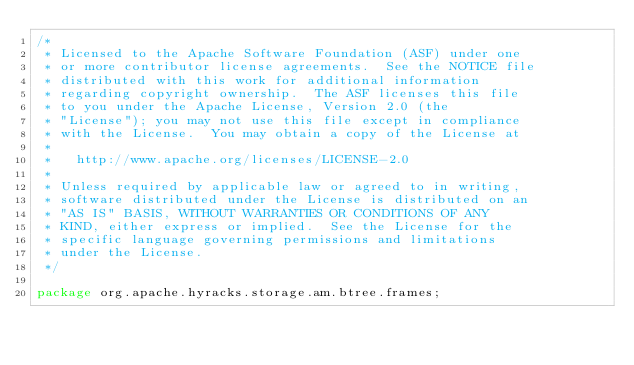<code> <loc_0><loc_0><loc_500><loc_500><_Java_>/*
 * Licensed to the Apache Software Foundation (ASF) under one
 * or more contributor license agreements.  See the NOTICE file
 * distributed with this work for additional information
 * regarding copyright ownership.  The ASF licenses this file
 * to you under the Apache License, Version 2.0 (the
 * "License"); you may not use this file except in compliance
 * with the License.  You may obtain a copy of the License at
 *
 *   http://www.apache.org/licenses/LICENSE-2.0
 *
 * Unless required by applicable law or agreed to in writing,
 * software distributed under the License is distributed on an
 * "AS IS" BASIS, WITHOUT WARRANTIES OR CONDITIONS OF ANY
 * KIND, either express or implied.  See the License for the
 * specific language governing permissions and limitations
 * under the License.
 */

package org.apache.hyracks.storage.am.btree.frames;
</code> 